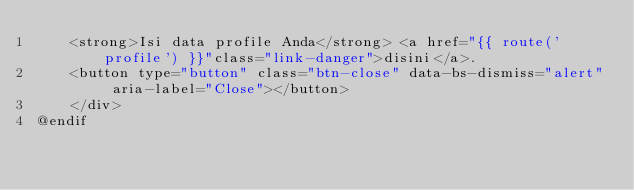Convert code to text. <code><loc_0><loc_0><loc_500><loc_500><_PHP_>    <strong>Isi data profile Anda</strong> <a href="{{ route('profile') }}"class="link-danger">disini</a>.
    <button type="button" class="btn-close" data-bs-dismiss="alert" aria-label="Close"></button>
    </div>
@endif</code> 